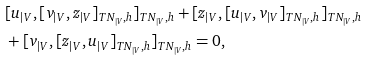Convert formula to latex. <formula><loc_0><loc_0><loc_500><loc_500>& [ u _ { | V } , [ v _ { | V } , z _ { | V } ] _ { T N _ { | V } , h } ] _ { T N _ { | V } , h } + [ z _ { | V } , [ u _ { | V } , v _ { | V } ] _ { T N _ { | V } , h } ] _ { T N _ { | V } , h } \\ & + [ v _ { | V } , [ z _ { | V } , u _ { | V } ] _ { T N _ { | V } , h } ] _ { T N _ { | V } , h } = 0 ,</formula> 